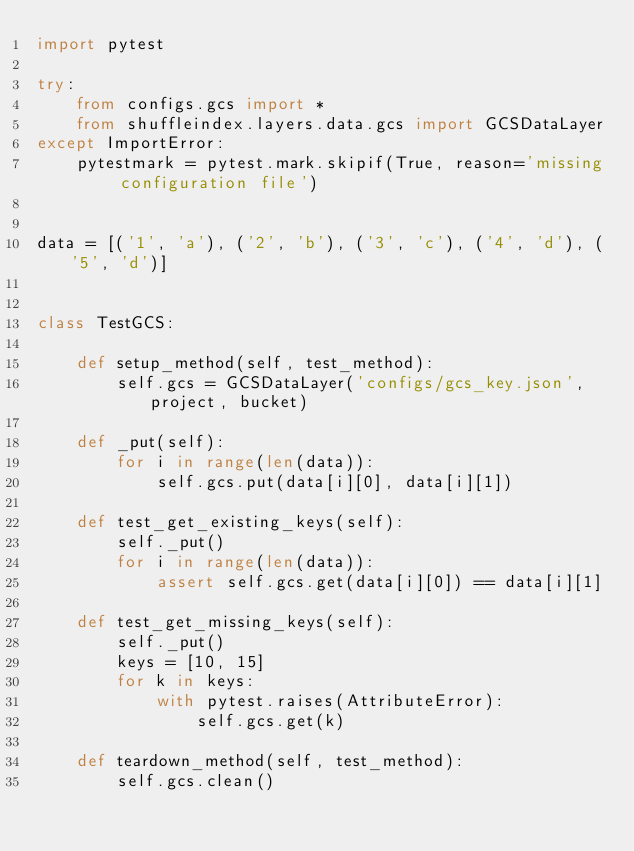Convert code to text. <code><loc_0><loc_0><loc_500><loc_500><_Python_>import pytest

try:
    from configs.gcs import *
    from shuffleindex.layers.data.gcs import GCSDataLayer
except ImportError:
    pytestmark = pytest.mark.skipif(True, reason='missing configuration file')


data = [('1', 'a'), ('2', 'b'), ('3', 'c'), ('4', 'd'), ('5', 'd')]


class TestGCS:

    def setup_method(self, test_method):
        self.gcs = GCSDataLayer('configs/gcs_key.json', project, bucket)

    def _put(self):
        for i in range(len(data)):
            self.gcs.put(data[i][0], data[i][1])

    def test_get_existing_keys(self):
        self._put()
        for i in range(len(data)):
            assert self.gcs.get(data[i][0]) == data[i][1]

    def test_get_missing_keys(self):
        self._put()
        keys = [10, 15]
        for k in keys:
            with pytest.raises(AttributeError):
                self.gcs.get(k)

    def teardown_method(self, test_method):
        self.gcs.clean()
</code> 